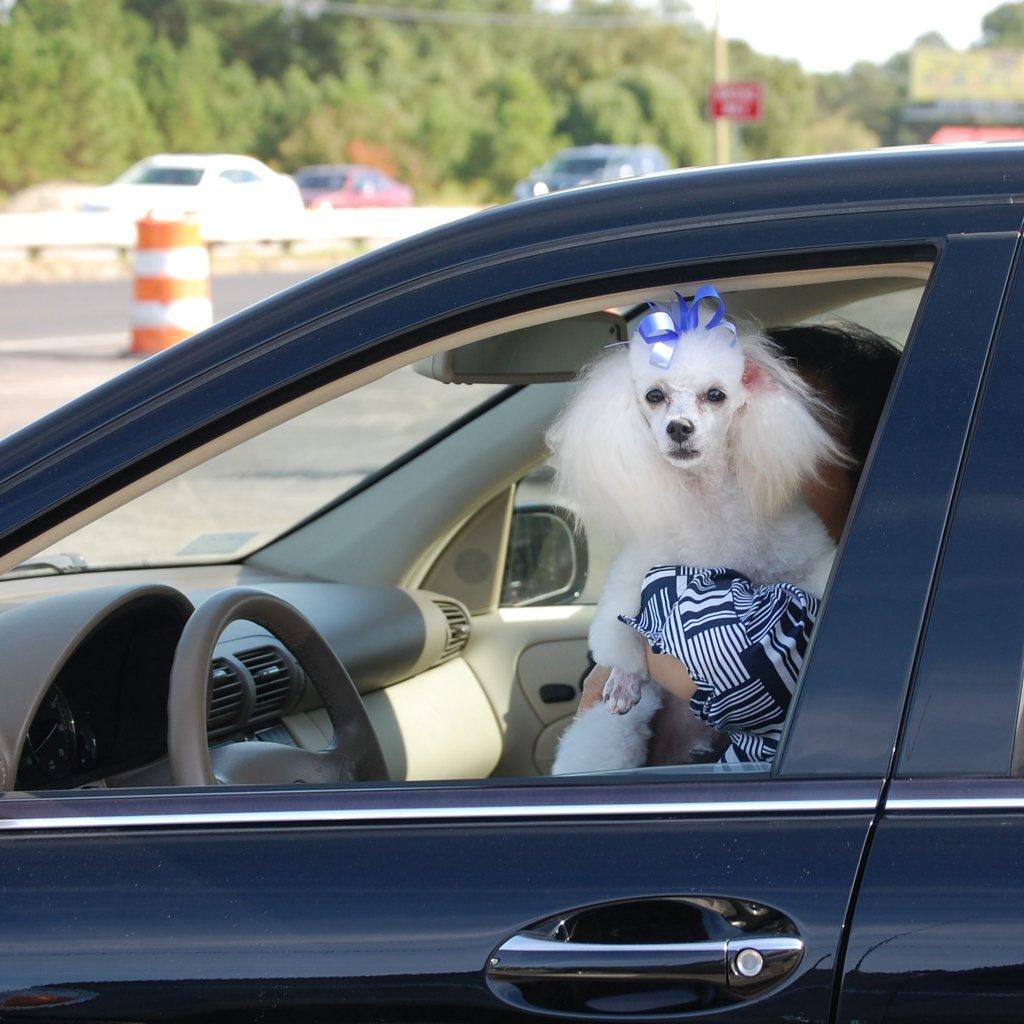How would you summarize this image in a sentence or two? In the image we can see there is a car window through which there is a dog who is peeing outside and the dog is in the lap of a person. Dog is in white colour and having a bow on his head. 